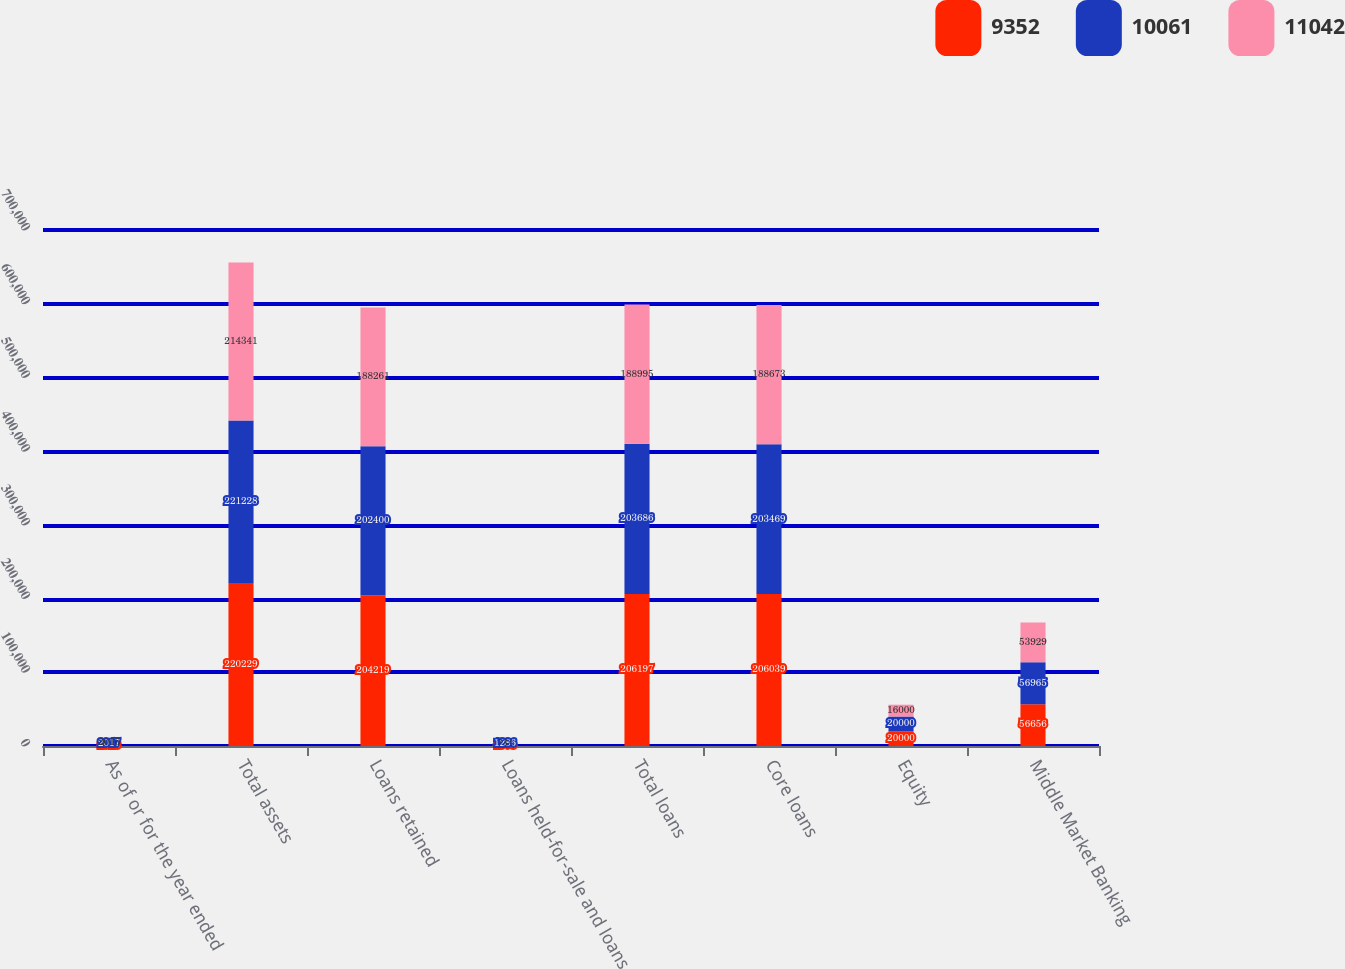<chart> <loc_0><loc_0><loc_500><loc_500><stacked_bar_chart><ecel><fcel>As of or for the year ended<fcel>Total assets<fcel>Loans retained<fcel>Loans held-for-sale and loans<fcel>Total loans<fcel>Core loans<fcel>Equity<fcel>Middle Market Banking<nl><fcel>9352<fcel>2018<fcel>220229<fcel>204219<fcel>1978<fcel>206197<fcel>206039<fcel>20000<fcel>56656<nl><fcel>10061<fcel>2017<fcel>221228<fcel>202400<fcel>1286<fcel>203686<fcel>203469<fcel>20000<fcel>56965<nl><fcel>11042<fcel>2016<fcel>214341<fcel>188261<fcel>734<fcel>188995<fcel>188673<fcel>16000<fcel>53929<nl></chart> 